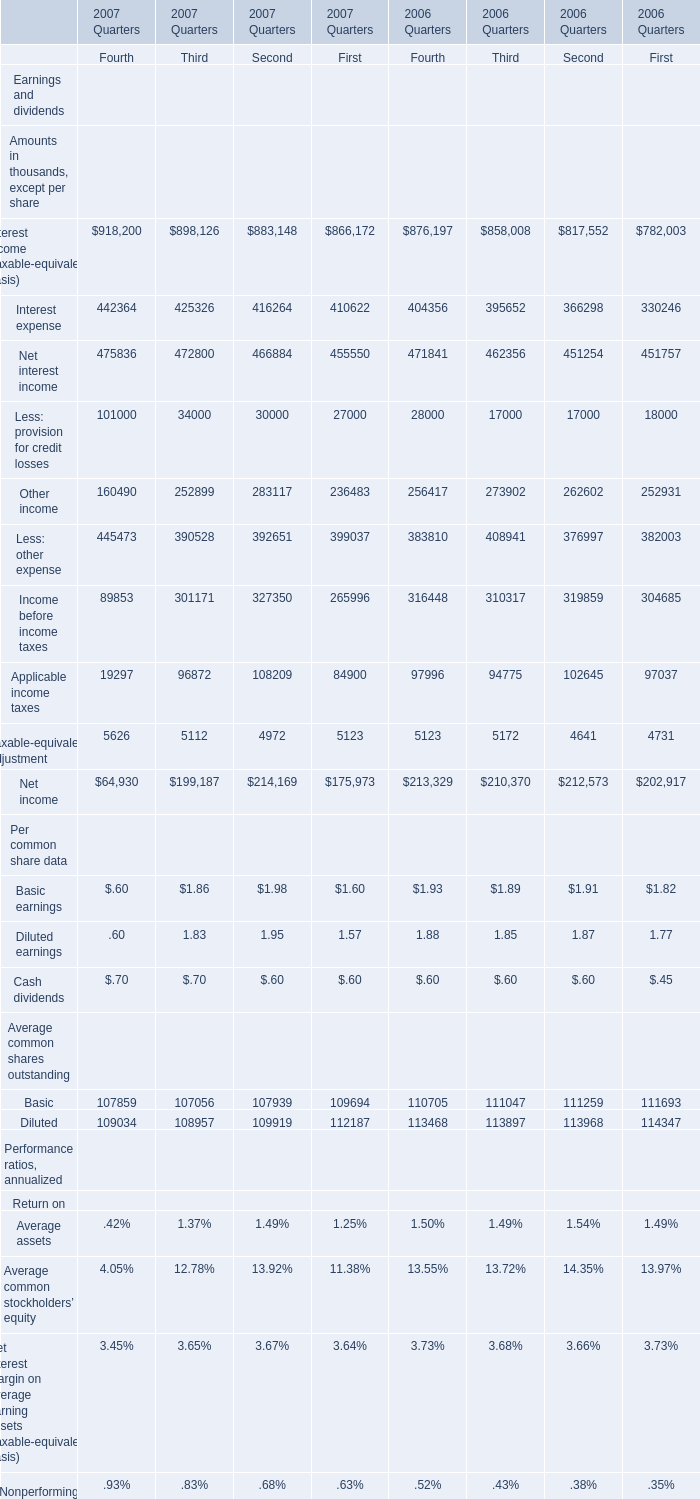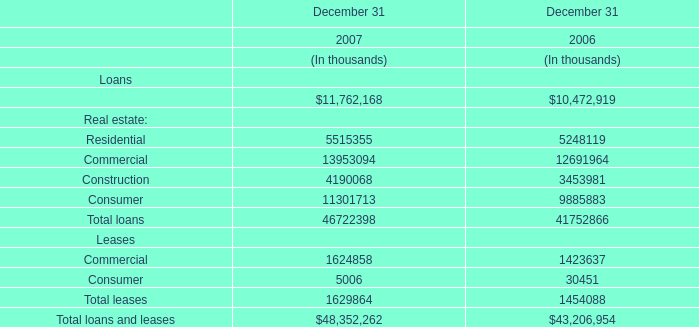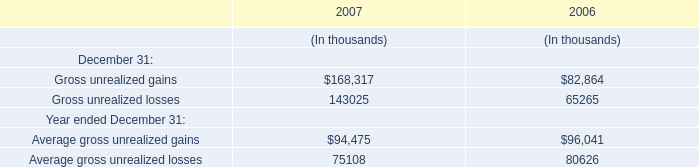What willTotal assets reach in 2008 if it continues to grow at its current rate? (in thousand) 
Computations: ((1 + ((61549 - 56575) / 56575)) * 61549)
Answer: 66960.30757. 